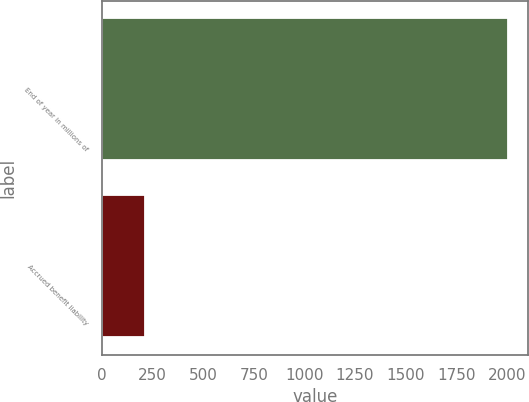<chart> <loc_0><loc_0><loc_500><loc_500><bar_chart><fcel>End of year in millions of<fcel>Accrued benefit liability<nl><fcel>2004<fcel>214<nl></chart> 